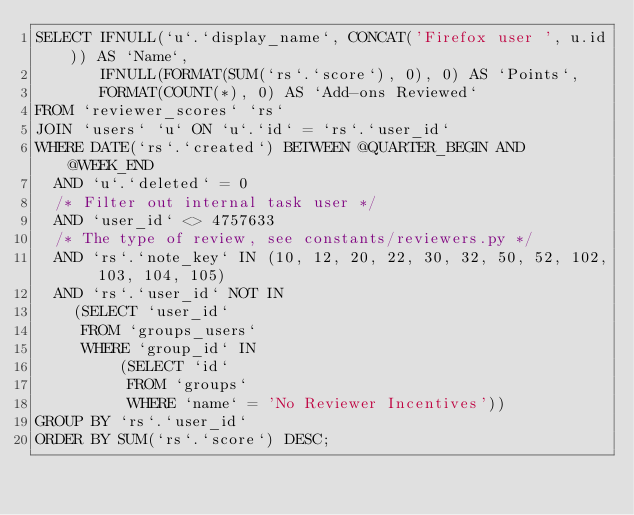Convert code to text. <code><loc_0><loc_0><loc_500><loc_500><_SQL_>SELECT IFNULL(`u`.`display_name`, CONCAT('Firefox user ', u.id)) AS `Name`,
       IFNULL(FORMAT(SUM(`rs`.`score`), 0), 0) AS `Points`,
       FORMAT(COUNT(*), 0) AS `Add-ons Reviewed`
FROM `reviewer_scores` `rs`
JOIN `users` `u` ON `u`.`id` = `rs`.`user_id`
WHERE DATE(`rs`.`created`) BETWEEN @QUARTER_BEGIN AND @WEEK_END
  AND `u`.`deleted` = 0
  /* Filter out internal task user */
  AND `user_id` <> 4757633
  /* The type of review, see constants/reviewers.py */
  AND `rs`.`note_key` IN (10, 12, 20, 22, 30, 32, 50, 52, 102, 103, 104, 105)
  AND `rs`.`user_id` NOT IN
    (SELECT `user_id`
     FROM `groups_users`
     WHERE `group_id` IN
         (SELECT `id`
          FROM `groups`
          WHERE `name` = 'No Reviewer Incentives'))
GROUP BY `rs`.`user_id`
ORDER BY SUM(`rs`.`score`) DESC;
</code> 